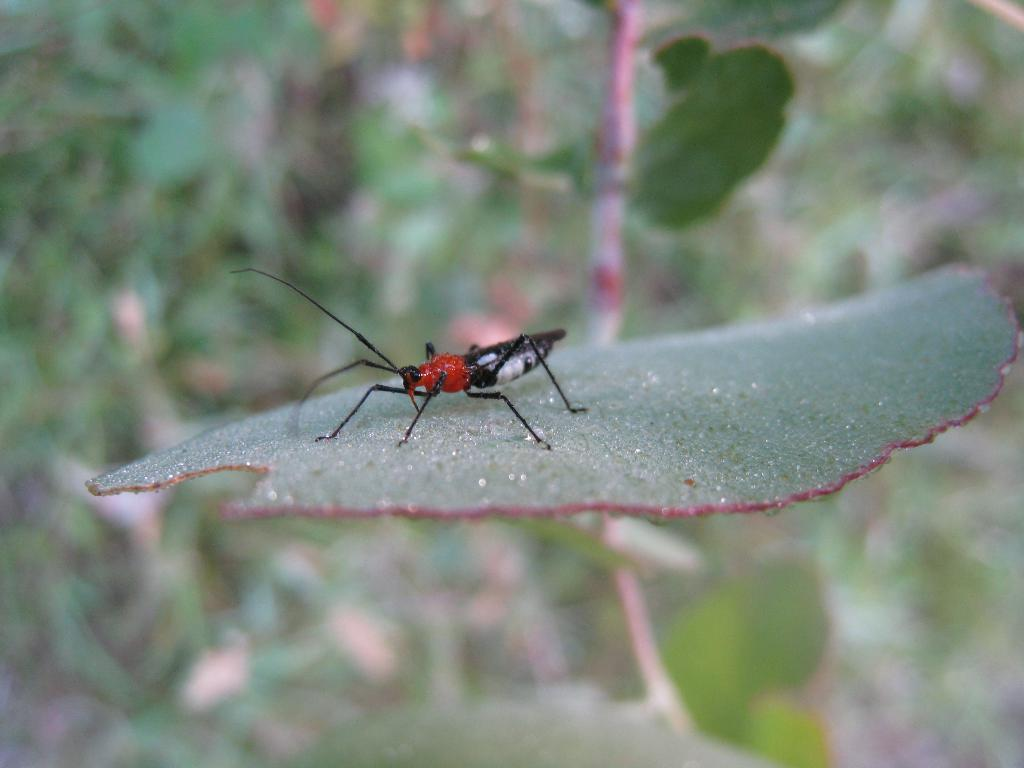What is on the leaf in the image? There is an insect on a leaf in the image. What else can be seen in the image besides the insect? There are plants visible in the image, although they appear blurry. What type of school can be seen in the image? There is no school present in the image; it features an insect on a leaf and blurry plants. 